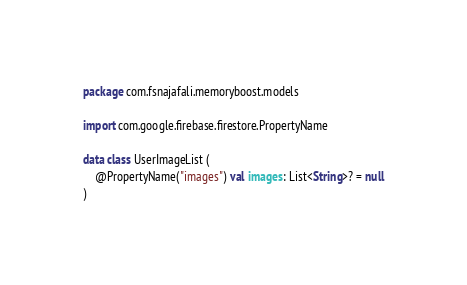Convert code to text. <code><loc_0><loc_0><loc_500><loc_500><_Kotlin_>package com.fsnajafali.memoryboost.models

import com.google.firebase.firestore.PropertyName

data class UserImageList (
    @PropertyName("images") val images: List<String>? = null
)</code> 